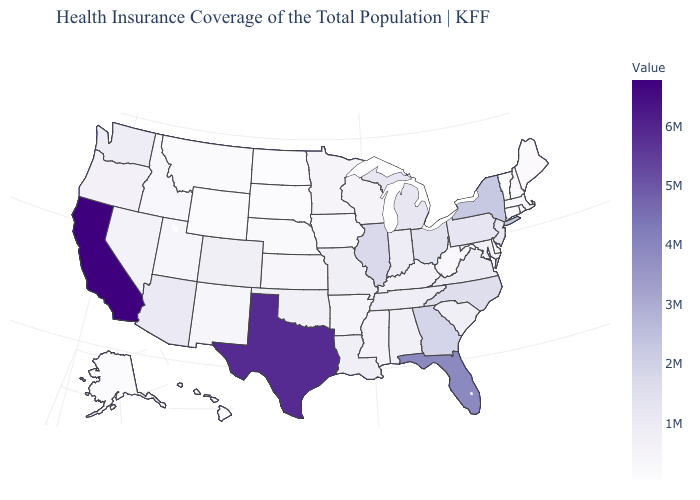Does Wisconsin have the highest value in the MidWest?
Give a very brief answer. No. Among the states that border New Mexico , which have the highest value?
Give a very brief answer. Texas. Which states have the lowest value in the South?
Short answer required. Delaware. Among the states that border Nebraska , which have the highest value?
Answer briefly. Colorado. 